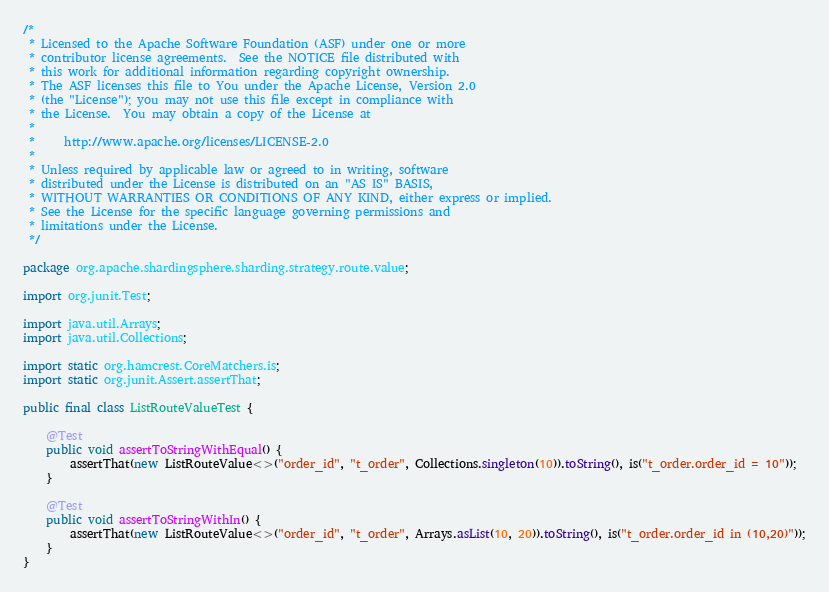<code> <loc_0><loc_0><loc_500><loc_500><_Java_>/*
 * Licensed to the Apache Software Foundation (ASF) under one or more
 * contributor license agreements.  See the NOTICE file distributed with
 * this work for additional information regarding copyright ownership.
 * The ASF licenses this file to You under the Apache License, Version 2.0
 * (the "License"); you may not use this file except in compliance with
 * the License.  You may obtain a copy of the License at
 *
 *     http://www.apache.org/licenses/LICENSE-2.0
 *
 * Unless required by applicable law or agreed to in writing, software
 * distributed under the License is distributed on an "AS IS" BASIS,
 * WITHOUT WARRANTIES OR CONDITIONS OF ANY KIND, either express or implied.
 * See the License for the specific language governing permissions and
 * limitations under the License.
 */

package org.apache.shardingsphere.sharding.strategy.route.value;

import org.junit.Test;

import java.util.Arrays;
import java.util.Collections;

import static org.hamcrest.CoreMatchers.is;
import static org.junit.Assert.assertThat;

public final class ListRouteValueTest {
    
    @Test
    public void assertToStringWithEqual() {
        assertThat(new ListRouteValue<>("order_id", "t_order", Collections.singleton(10)).toString(), is("t_order.order_id = 10"));
    }
    
    @Test
    public void assertToStringWithIn() {
        assertThat(new ListRouteValue<>("order_id", "t_order", Arrays.asList(10, 20)).toString(), is("t_order.order_id in (10,20)"));
    }
}
</code> 